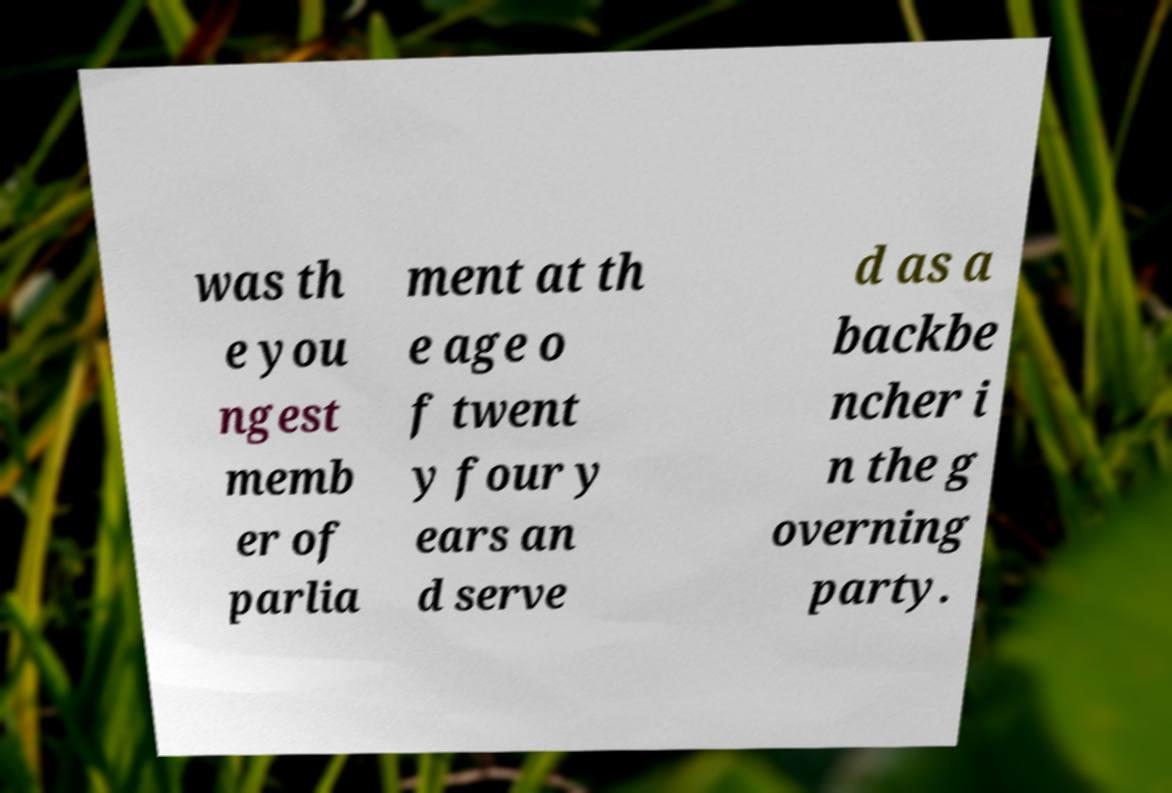There's text embedded in this image that I need extracted. Can you transcribe it verbatim? was th e you ngest memb er of parlia ment at th e age o f twent y four y ears an d serve d as a backbe ncher i n the g overning party. 